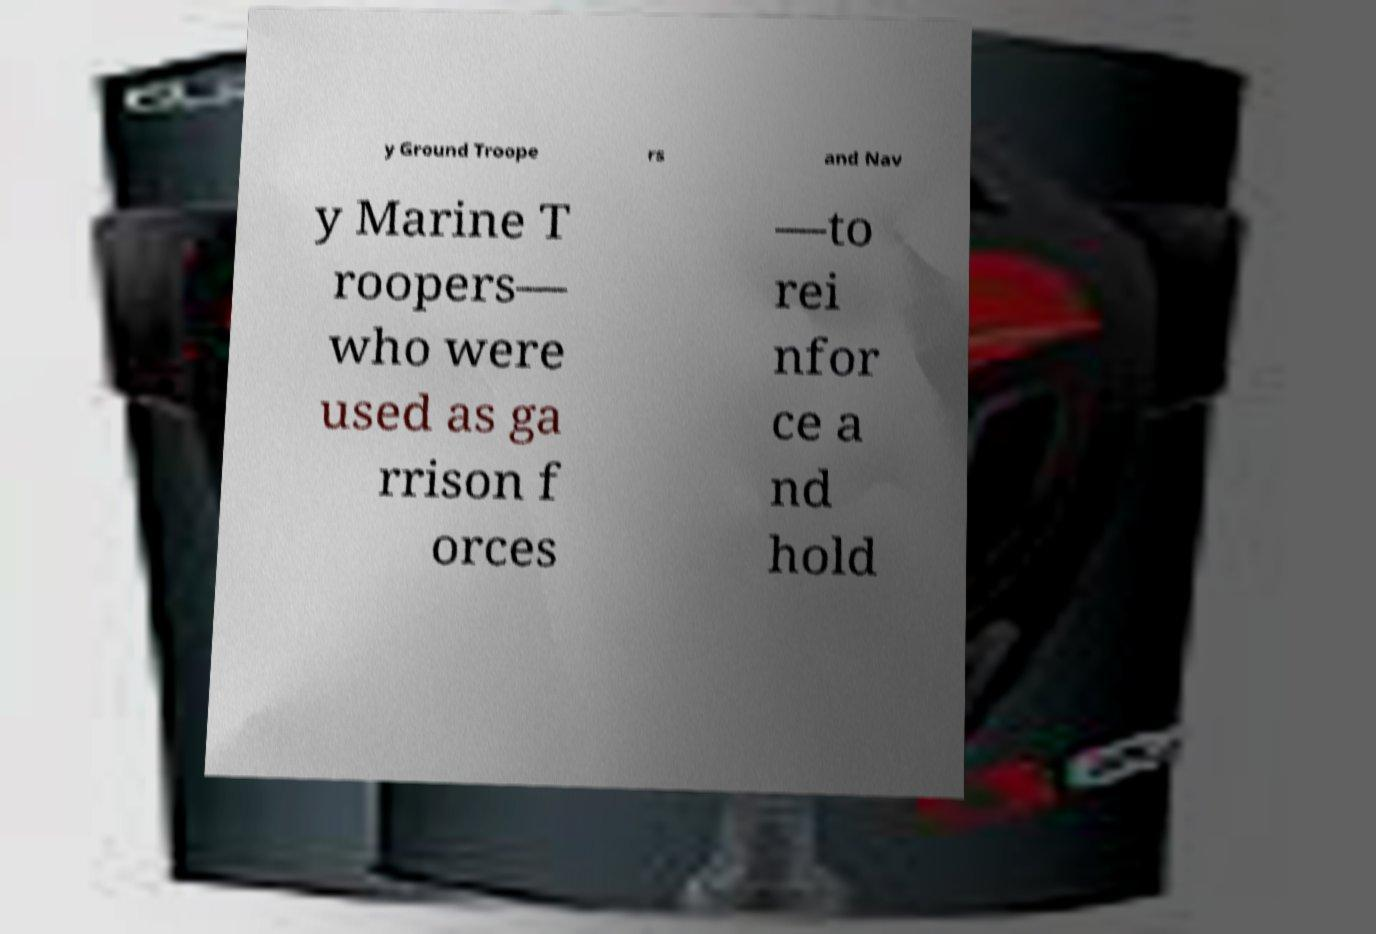There's text embedded in this image that I need extracted. Can you transcribe it verbatim? y Ground Troope rs and Nav y Marine T roopers— who were used as ga rrison f orces —to rei nfor ce a nd hold 